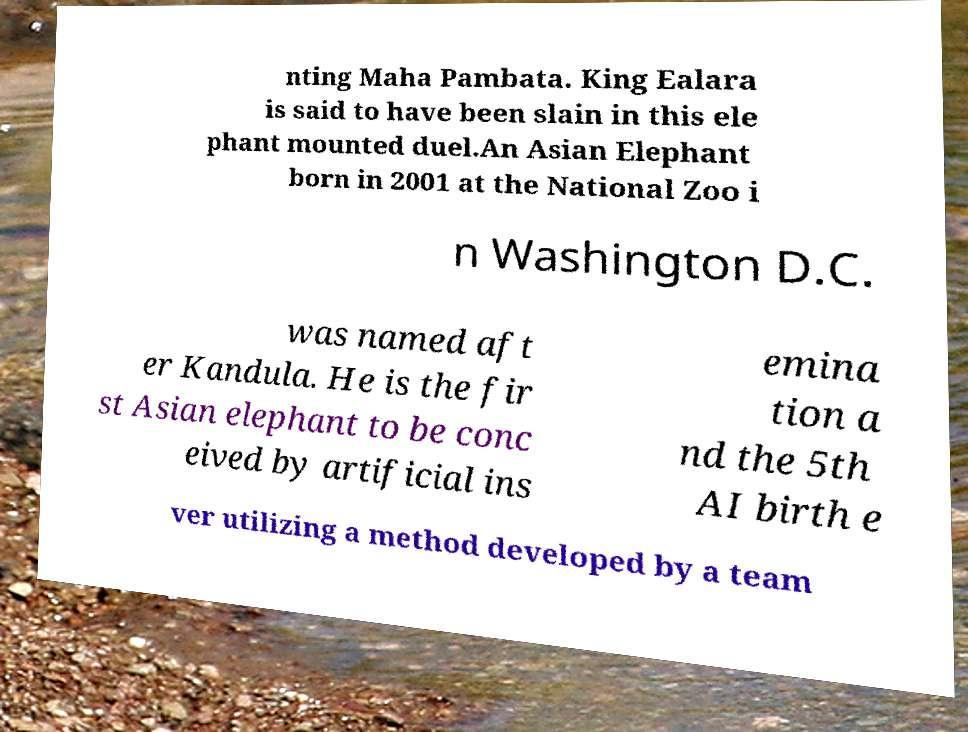Can you accurately transcribe the text from the provided image for me? nting Maha Pambata. King Ealara is said to have been slain in this ele phant mounted duel.An Asian Elephant born in 2001 at the National Zoo i n Washington D.C. was named aft er Kandula. He is the fir st Asian elephant to be conc eived by artificial ins emina tion a nd the 5th AI birth e ver utilizing a method developed by a team 